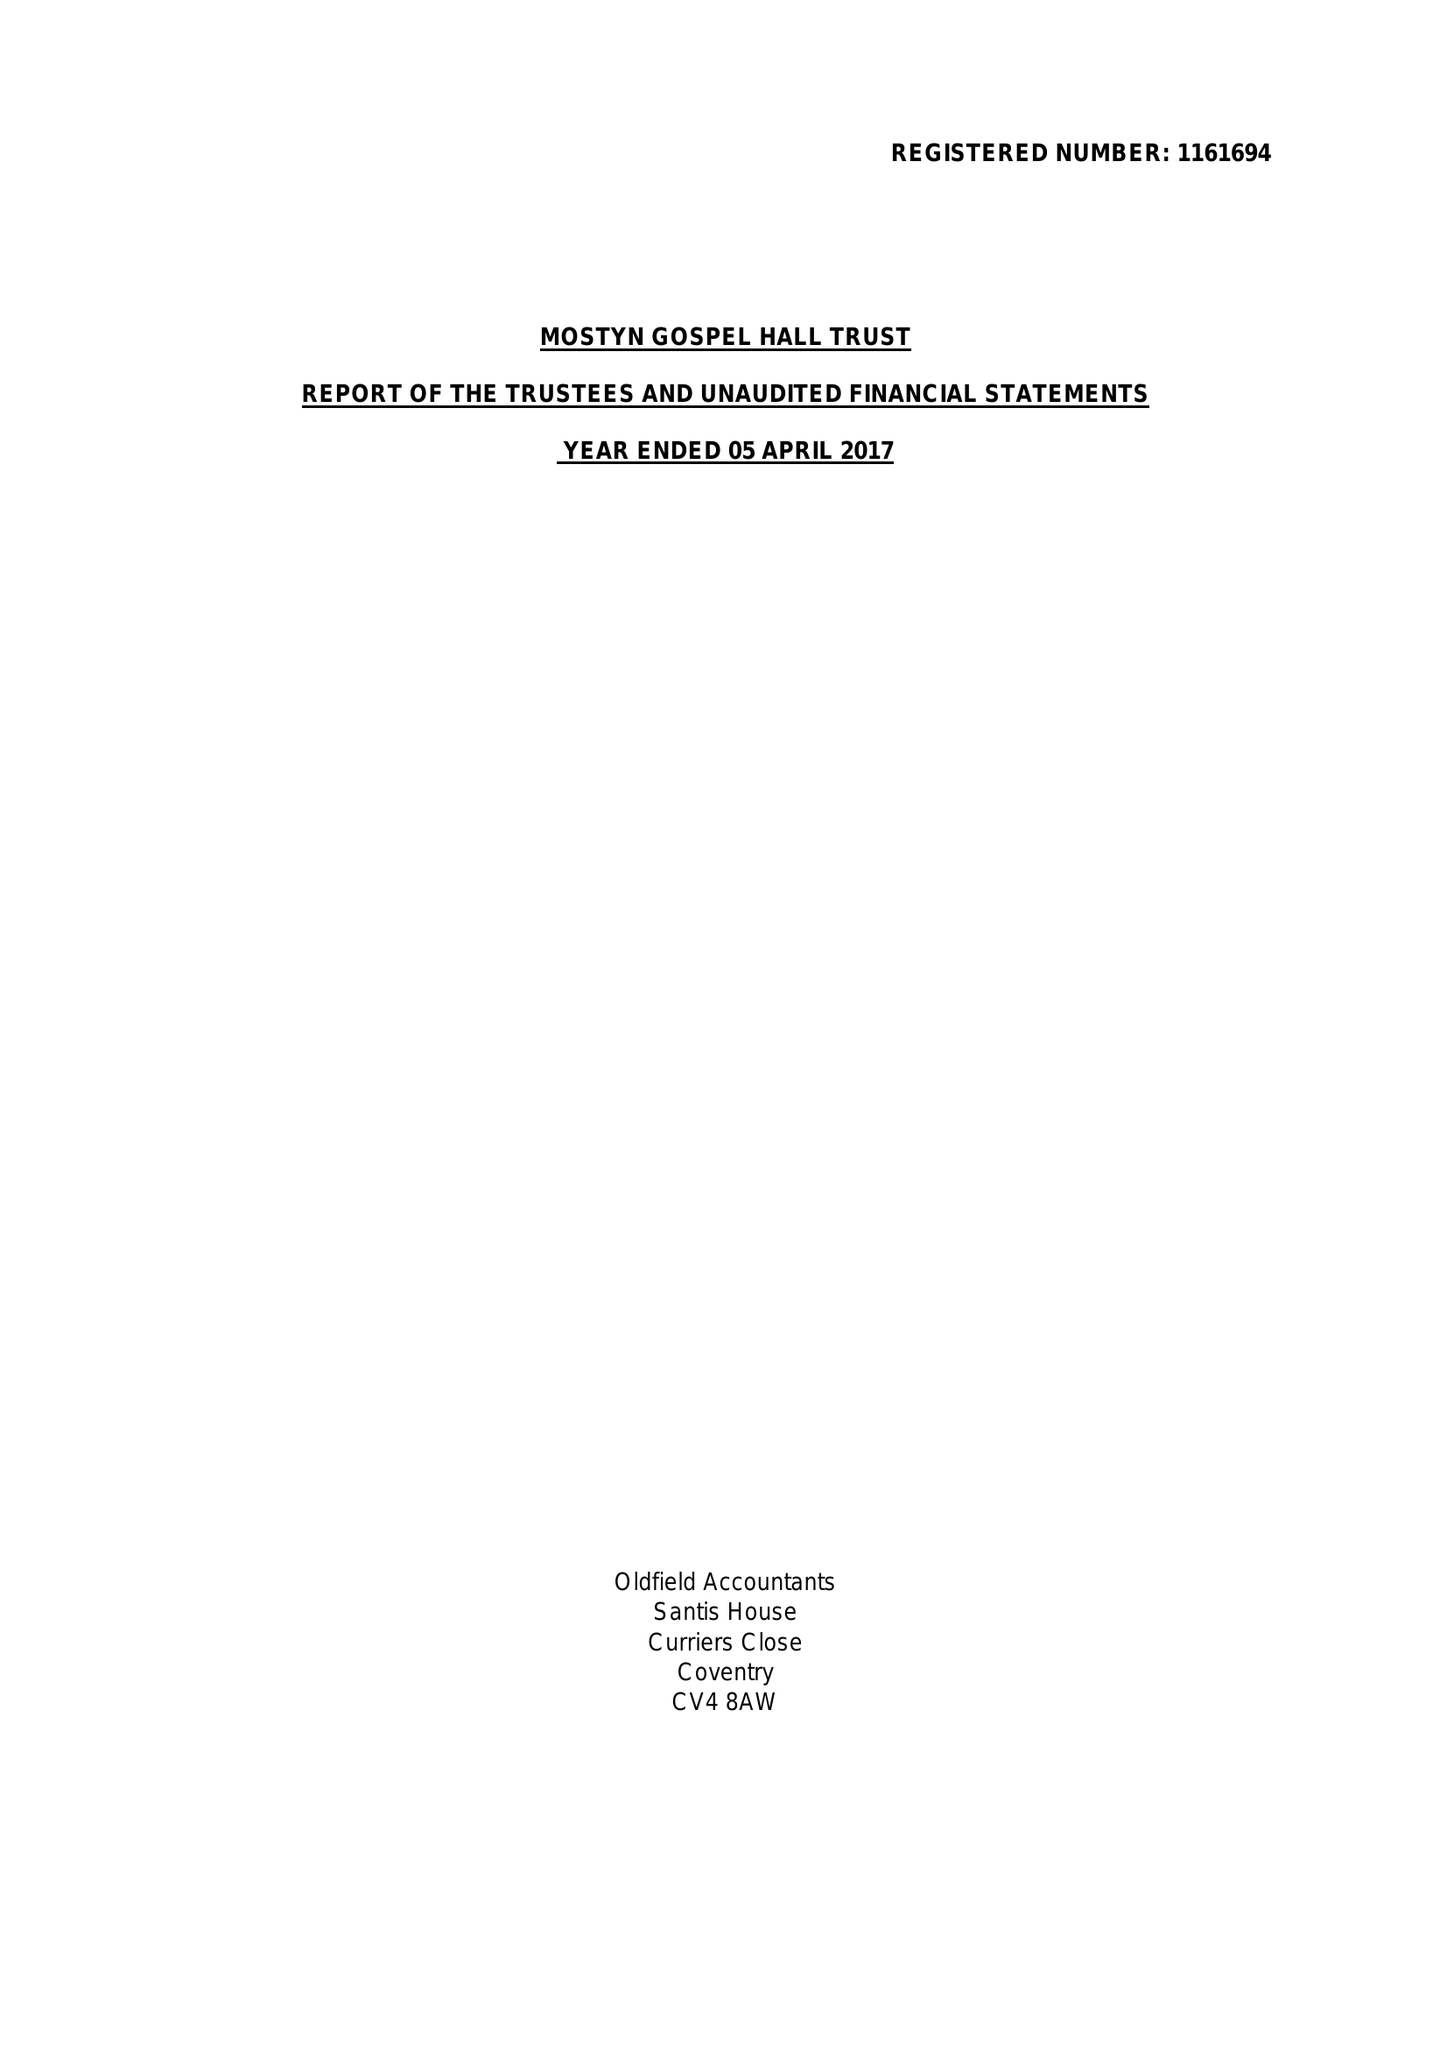What is the value for the income_annually_in_british_pounds?
Answer the question using a single word or phrase. 70998.00 